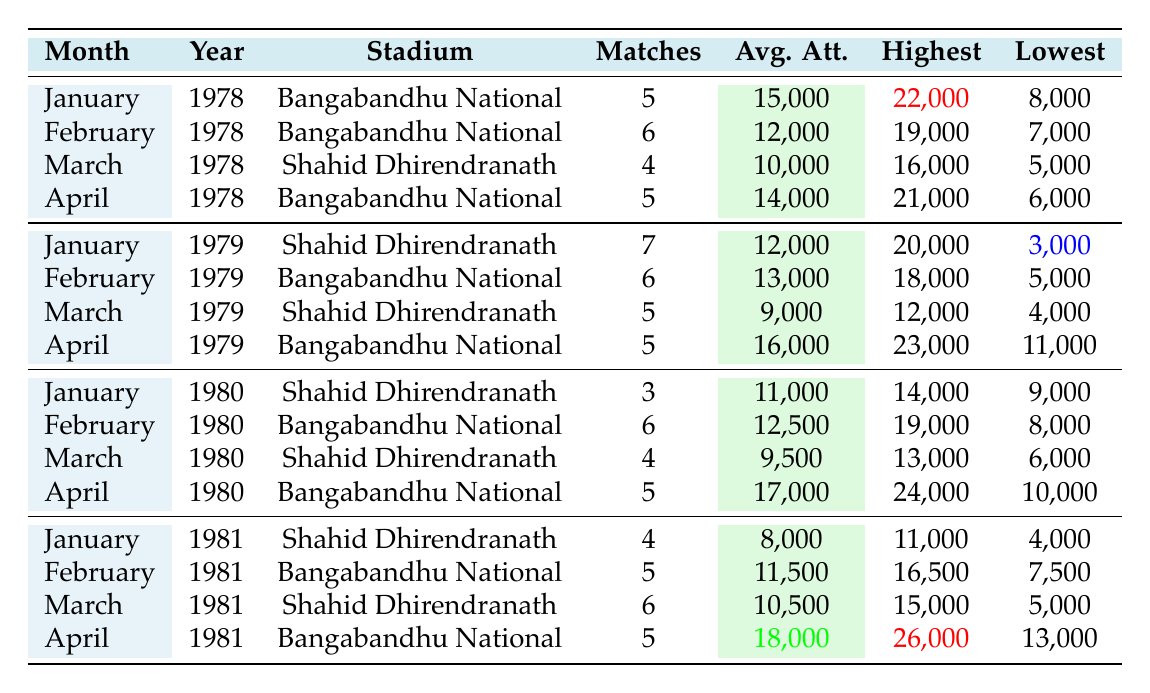What was the highest attendance recorded in January 1978? The table shows that the highest attendance in January 1978 at the Bangabandhu National Stadium was highlighted as 22,000.
Answer: 22,000 What was the average attendance for matches in April 1981? The table indicates that the average attendance in April 1981 at the Bangabandhu National Stadium was highlighted as 18,000.
Answer: 18,000 Which stadium had the highest average attendance in April 1979? The table shows that the Bangabandhu National Stadium had an average attendance of 16,000 in April 1979, which is higher compared to Shahid Dhirendranath's attendance of 9,000 in the same month.
Answer: Bangabandhu National Stadium What is the difference between the lowest attendance in January 1979 and the lowest attendance in January 1981? The lowest attendance in January 1979 was 3,000, while in January 1981 it was 4,000. The difference is 4,000 - 3,000 = 1,000.
Answer: 1,000 Which month in 1980 had the highest highest attendance? In 1980, April had the highest attendance at 24,000, as compared to January (14,000), February (19,000), and March (13,000), making April the highest.
Answer: April What was the total number of matches played in February across 1978 and 1979? In February 1978, there were 6 matches and in February 1979, there were also 6 matches. The total is 6 + 6 = 12.
Answer: 12 Was the average attendance in March 1980 lower than the average attendance in March 1979? The average attendance in March 1980 was 9,500 while in March 1979 it was 9,000. Since 9,500 is greater than 9,000, the statement is false.
Answer: No What was the overall trend of average attendance from January 1978 to April 1981? Observing the data, there was an initial increase in average attendance during the 1978 and 1979 seasons, but fluctuations occurred until 1981 where the average in January was 8,000, indicating a downward trend overall towards 1981.
Answer: Downward trend What was the highest attendance recorded in February for the years 1978 and 1979 combined? The highest attendance in February 1978 was 19,000 and in February 1979 was 18,000. The highest of these two is 19,000.
Answer: 19,000 How many matches were played at the Shahid Dhirendranath Stadium in 1980? In January, 3 matches were played, in March 4 matches, and February had none; thus, 3 + 4 = 7 matches were played in total at Shahid Dhirendranath Stadium in 1980.
Answer: 7 